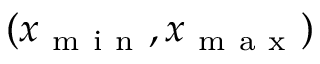<formula> <loc_0><loc_0><loc_500><loc_500>( x _ { m i n } , x _ { m a x } )</formula> 